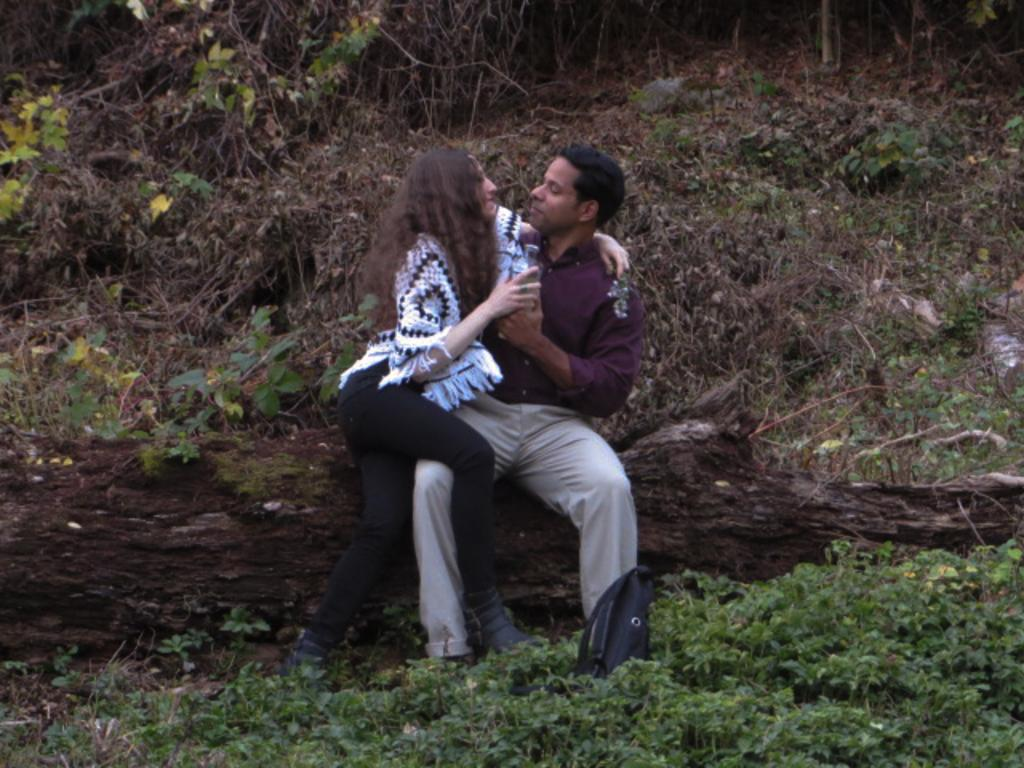What type of living organisms can be seen in the image? Plants can be seen in the image. What are the two people in the image doing? They are sitting on a tree stem. What is the woman holding in the image? The woman is holding a bottle. What type of orange is the woman eating in the image? There is no orange present in the image; the woman is holding a bottle. What hobbies do the people in the image have? The provided facts do not give information about the people's hobbies. 